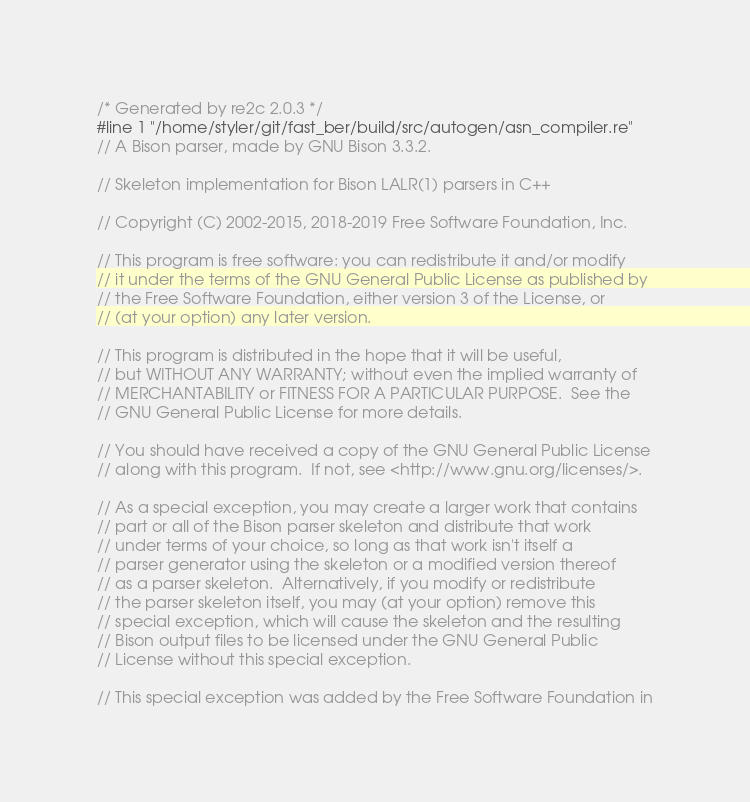Convert code to text. <code><loc_0><loc_0><loc_500><loc_500><_C++_>/* Generated by re2c 2.0.3 */
#line 1 "/home/styler/git/fast_ber/build/src/autogen/asn_compiler.re"
// A Bison parser, made by GNU Bison 3.3.2.

// Skeleton implementation for Bison LALR(1) parsers in C++

// Copyright (C) 2002-2015, 2018-2019 Free Software Foundation, Inc.

// This program is free software: you can redistribute it and/or modify
// it under the terms of the GNU General Public License as published by
// the Free Software Foundation, either version 3 of the License, or
// (at your option) any later version.

// This program is distributed in the hope that it will be useful,
// but WITHOUT ANY WARRANTY; without even the implied warranty of
// MERCHANTABILITY or FITNESS FOR A PARTICULAR PURPOSE.  See the
// GNU General Public License for more details.

// You should have received a copy of the GNU General Public License
// along with this program.  If not, see <http://www.gnu.org/licenses/>.

// As a special exception, you may create a larger work that contains
// part or all of the Bison parser skeleton and distribute that work
// under terms of your choice, so long as that work isn't itself a
// parser generator using the skeleton or a modified version thereof
// as a parser skeleton.  Alternatively, if you modify or redistribute
// the parser skeleton itself, you may (at your option) remove this
// special exception, which will cause the skeleton and the resulting
// Bison output files to be licensed under the GNU General Public
// License without this special exception.

// This special exception was added by the Free Software Foundation in</code> 